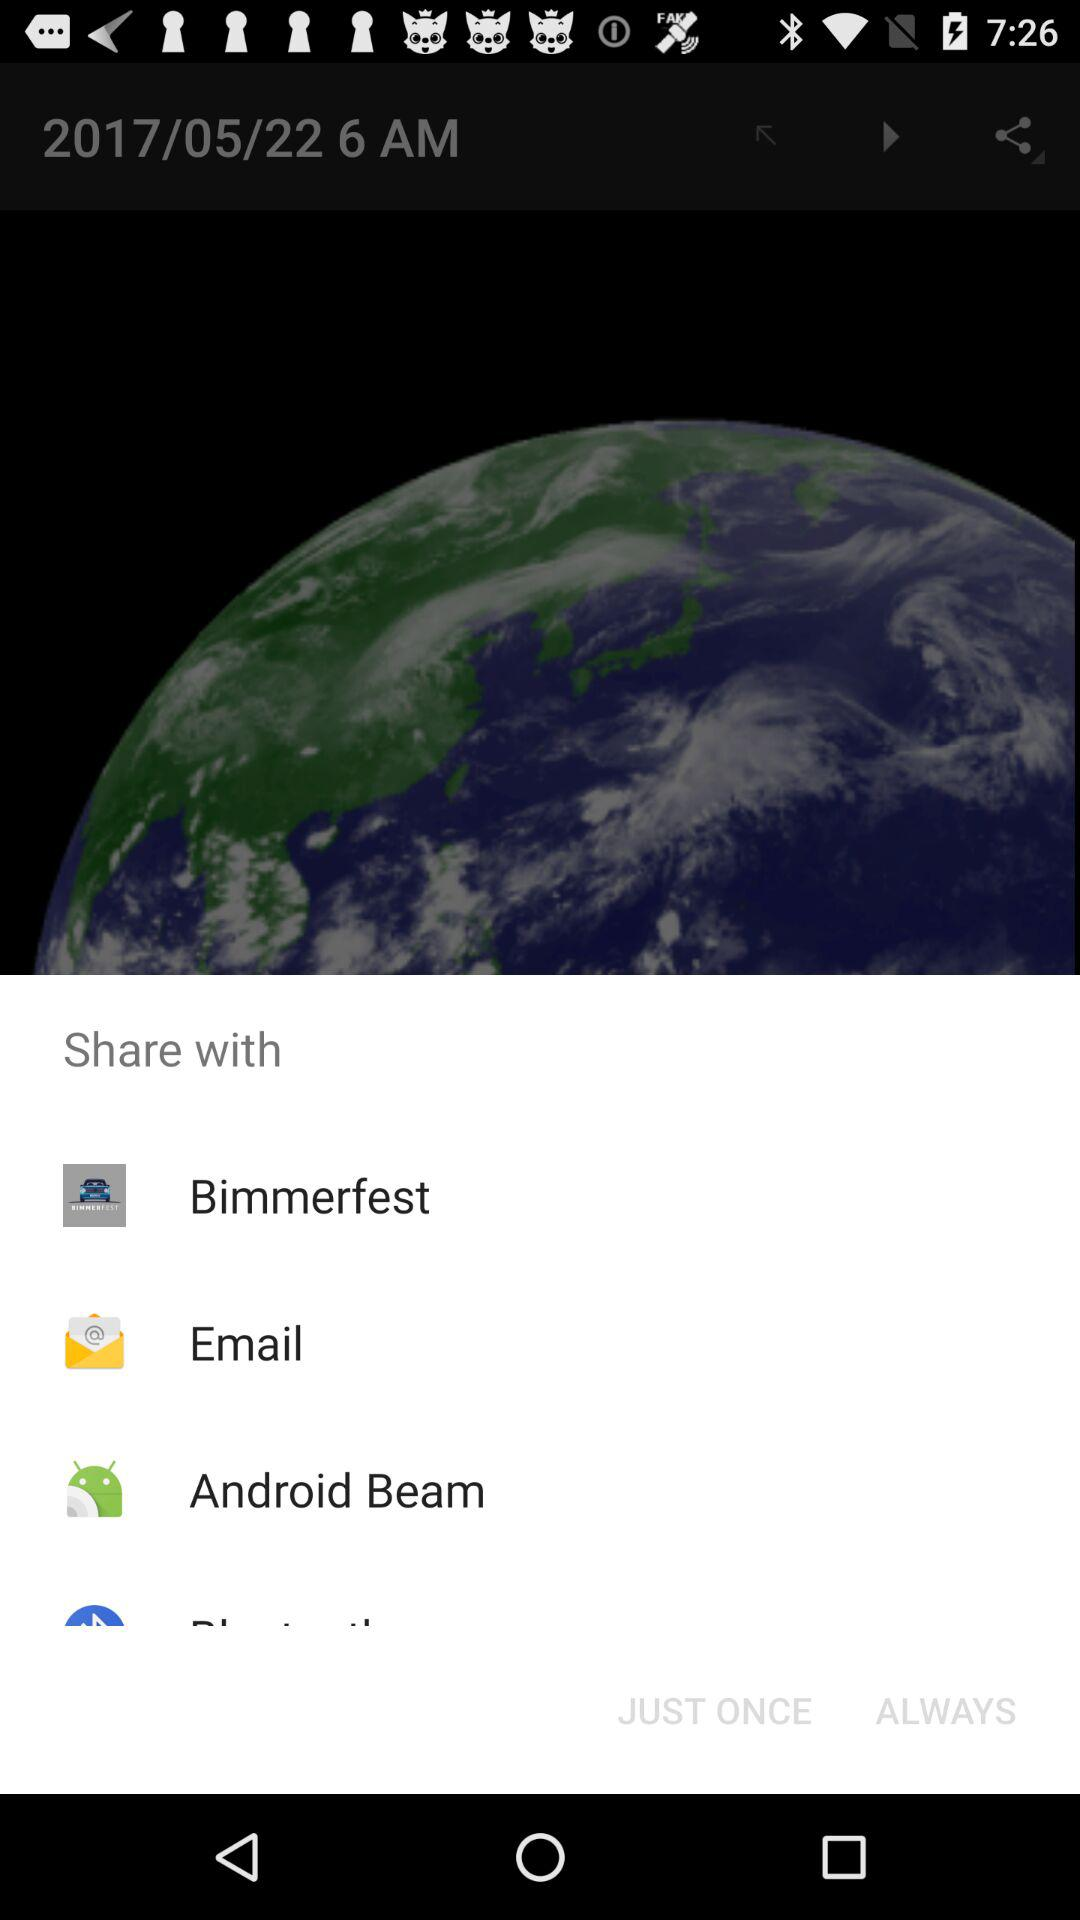Through what applications can content be shared? The applications are: "Bimmerfest", "Email", and "Android Beam". 